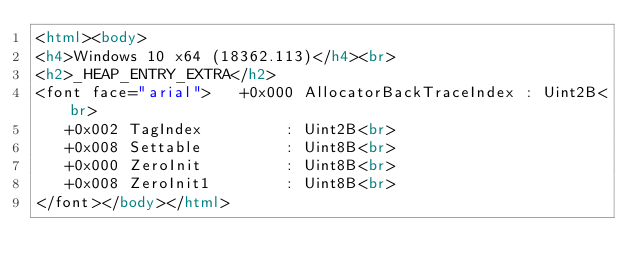<code> <loc_0><loc_0><loc_500><loc_500><_HTML_><html><body>
<h4>Windows 10 x64 (18362.113)</h4><br>
<h2>_HEAP_ENTRY_EXTRA</h2>
<font face="arial">   +0x000 AllocatorBackTraceIndex : Uint2B<br>
   +0x002 TagIndex         : Uint2B<br>
   +0x008 Settable         : Uint8B<br>
   +0x000 ZeroInit         : Uint8B<br>
   +0x008 ZeroInit1        : Uint8B<br>
</font></body></html></code> 